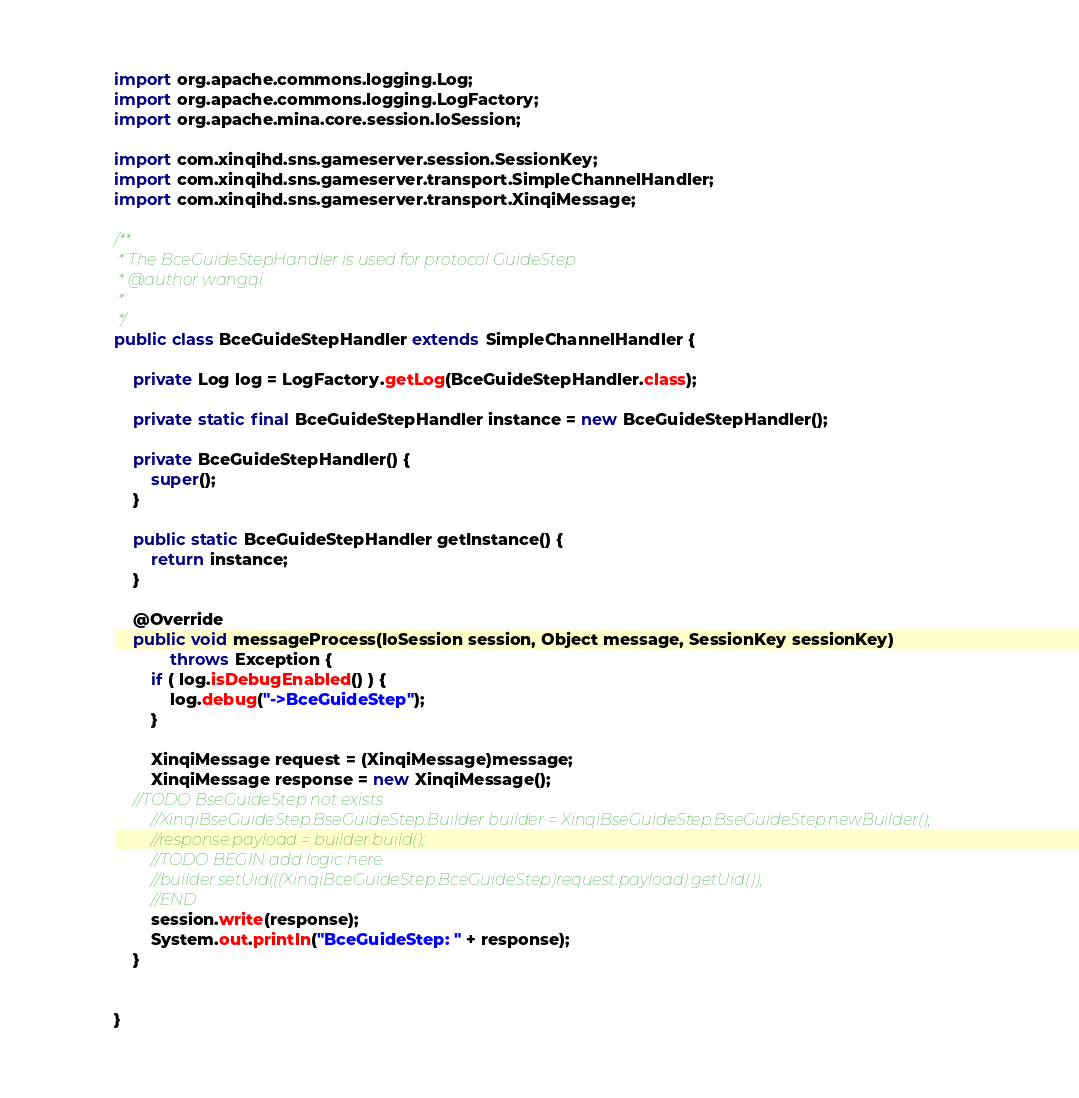<code> <loc_0><loc_0><loc_500><loc_500><_Java_>import org.apache.commons.logging.Log;
import org.apache.commons.logging.LogFactory;
import org.apache.mina.core.session.IoSession;

import com.xinqihd.sns.gameserver.session.SessionKey;
import com.xinqihd.sns.gameserver.transport.SimpleChannelHandler;
import com.xinqihd.sns.gameserver.transport.XinqiMessage;

/**
 * The BceGuideStepHandler is used for protocol GuideStep 
 * @author wangqi
 *
 */
public class BceGuideStepHandler extends SimpleChannelHandler {
	
	private Log log = LogFactory.getLog(BceGuideStepHandler.class);
	
	private static final BceGuideStepHandler instance = new BceGuideStepHandler();
	
	private BceGuideStepHandler() {
		super();
	}

	public static BceGuideStepHandler getInstance() {
		return instance;
	}

	@Override
	public void messageProcess(IoSession session, Object message, SessionKey sessionKey)
			throws Exception {
		if ( log.isDebugEnabled() ) {
			log.debug("->BceGuideStep");
		}
		
		XinqiMessage request = (XinqiMessage)message;
		XinqiMessage response = new XinqiMessage();
    //TODO BseGuideStep not exists
		//XinqiBseGuideStep.BseGuideStep.Builder builder = XinqiBseGuideStep.BseGuideStep.newBuilder();
		//response.payload = builder.build();
		//TODO BEGIN add logic here.
		//builder.setUid(((XinqiBceGuideStep.BceGuideStep)request.payload).getUid());
		//END
		session.write(response);
		System.out.println("BceGuideStep: " + response);
	}
	
	
}
</code> 